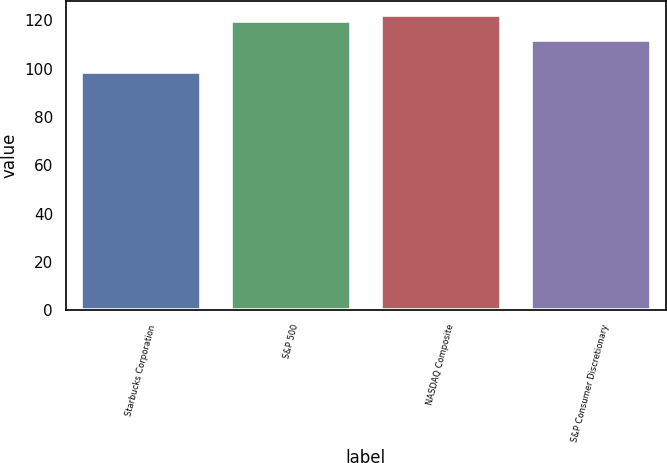<chart> <loc_0><loc_0><loc_500><loc_500><bar_chart><fcel>Starbucks Corporation<fcel>S&P 500<fcel>NASDAQ Composite<fcel>S&P Consumer Discretionary<nl><fcel>98.58<fcel>119.73<fcel>122.04<fcel>111.77<nl></chart> 